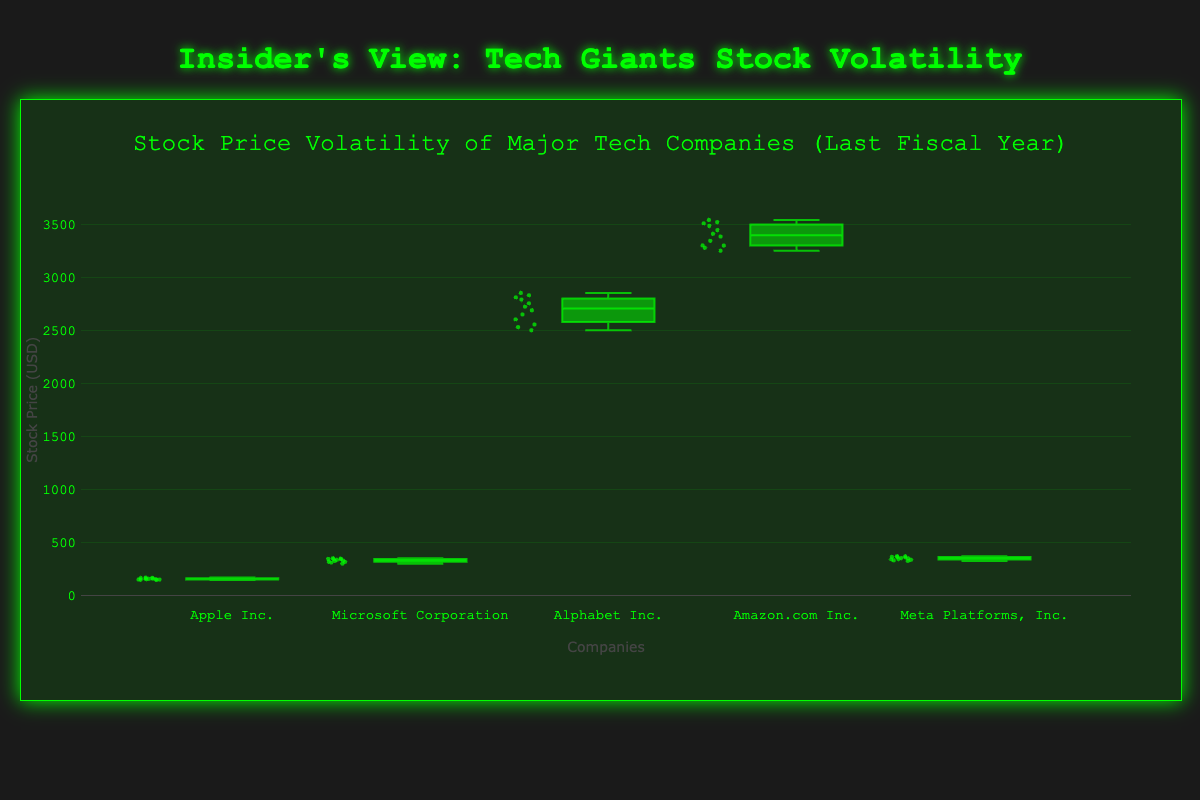Which company's stock prices had the highest median value? To determine the company with the highest median stock price, look for the median line inside each box plot. Alphabet Inc. shows the highest median value.
Answer: Alphabet Inc What's the interquartile range (IQR) for Microsoft Corporation? The IQR is the difference between the third quartile (Q3) and the first quartile (Q1). For Microsoft Corporation, identify the values of Q3 and Q1 from the box plot and compute the difference. Suppose Q3 is around 345 and Q1 is about 315, then the IQR is 345 - 315.
Answer: 30 Which company exhibits the greatest stock price variance? The greatest variance can be inferred from the width of the box (IQR) and the spread of the whiskers. Amazon.com Inc. has the widest box and whiskers, suggesting the highest variance.
Answer: Amazon.com Inc Between Apple Inc. and Meta Platforms, Inc., which has a higher maximum stock price? Compare the top whiskers of the box plots for both companies. Meta Platforms, Inc. has a higher top whisker, indicating a higher maximum stock price.
Answer: Meta Platforms, Inc How many stock prices were recorded for each company? Since there are data points plotted on each company's box plot, count them for one company. Each company has 12 data points, corresponding to 12 months.
Answer: 12 What's the approximate range of stock prices for Alphabet Inc.? The range is calculated by subtracting the minimum value from the maximum value in the whisker plot. Suppose the minimum is around 2500 and the maximum is about 2850, then the range is 2850 - 2500.
Answer: 350 Which company has the smallest interquartile range (IQR)? The smallest IQR is observed by examining the height of the boxes. Apple Inc. seems to have the smallest IQR among the companies.
Answer: Apple Inc Is the median stock price of Amazon.com Inc. higher or lower than the third quartile (Q3) price of Microsoft Corporation? Find the median line of Amazon.com Inc. and compare it with the Q3 line of Microsoft Corporation. The median line of Amazon is higher.
Answer: Higher What is the general trend of stock prices over the year for Microsoft Corporation? Observing the distribution and spread of stock prices in the box plot, Microsoft's stock prices show a general increasing trend.
Answer: Increasing trend 